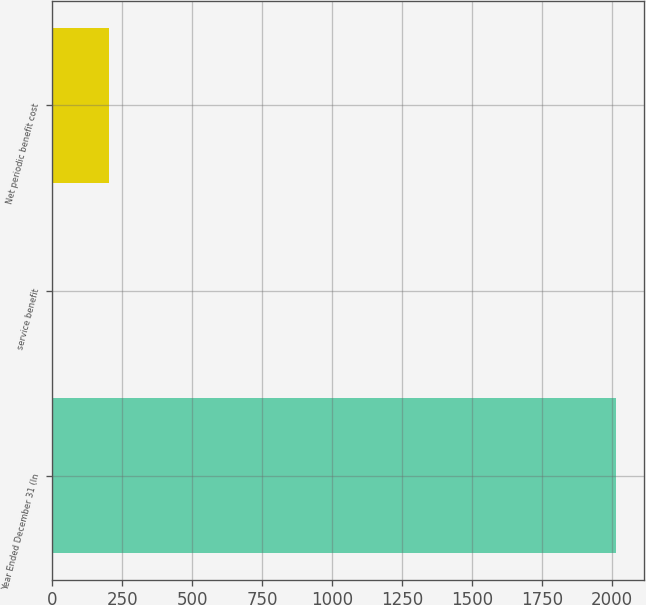Convert chart. <chart><loc_0><loc_0><loc_500><loc_500><bar_chart><fcel>Year Ended December 31 (In<fcel>service benefit<fcel>Net periodic benefit cost<nl><fcel>2015<fcel>1<fcel>202.4<nl></chart> 